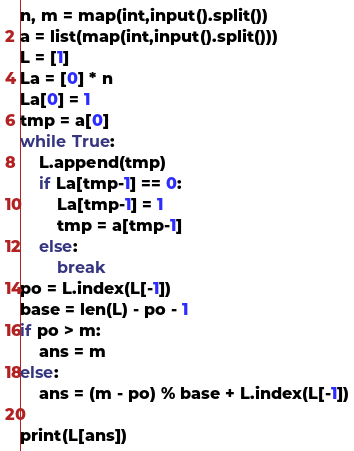Convert code to text. <code><loc_0><loc_0><loc_500><loc_500><_Python_>n, m = map(int,input().split())
a = list(map(int,input().split()))
L = [1]
La = [0] * n
La[0] = 1
tmp = a[0]
while True:
    L.append(tmp)
    if La[tmp-1] == 0:
        La[tmp-1] = 1
        tmp = a[tmp-1]
    else:        
        break
po = L.index(L[-1])
base = len(L) - po - 1
if po > m:
    ans = m
else:
    ans = (m - po) % base + L.index(L[-1])

print(L[ans])</code> 